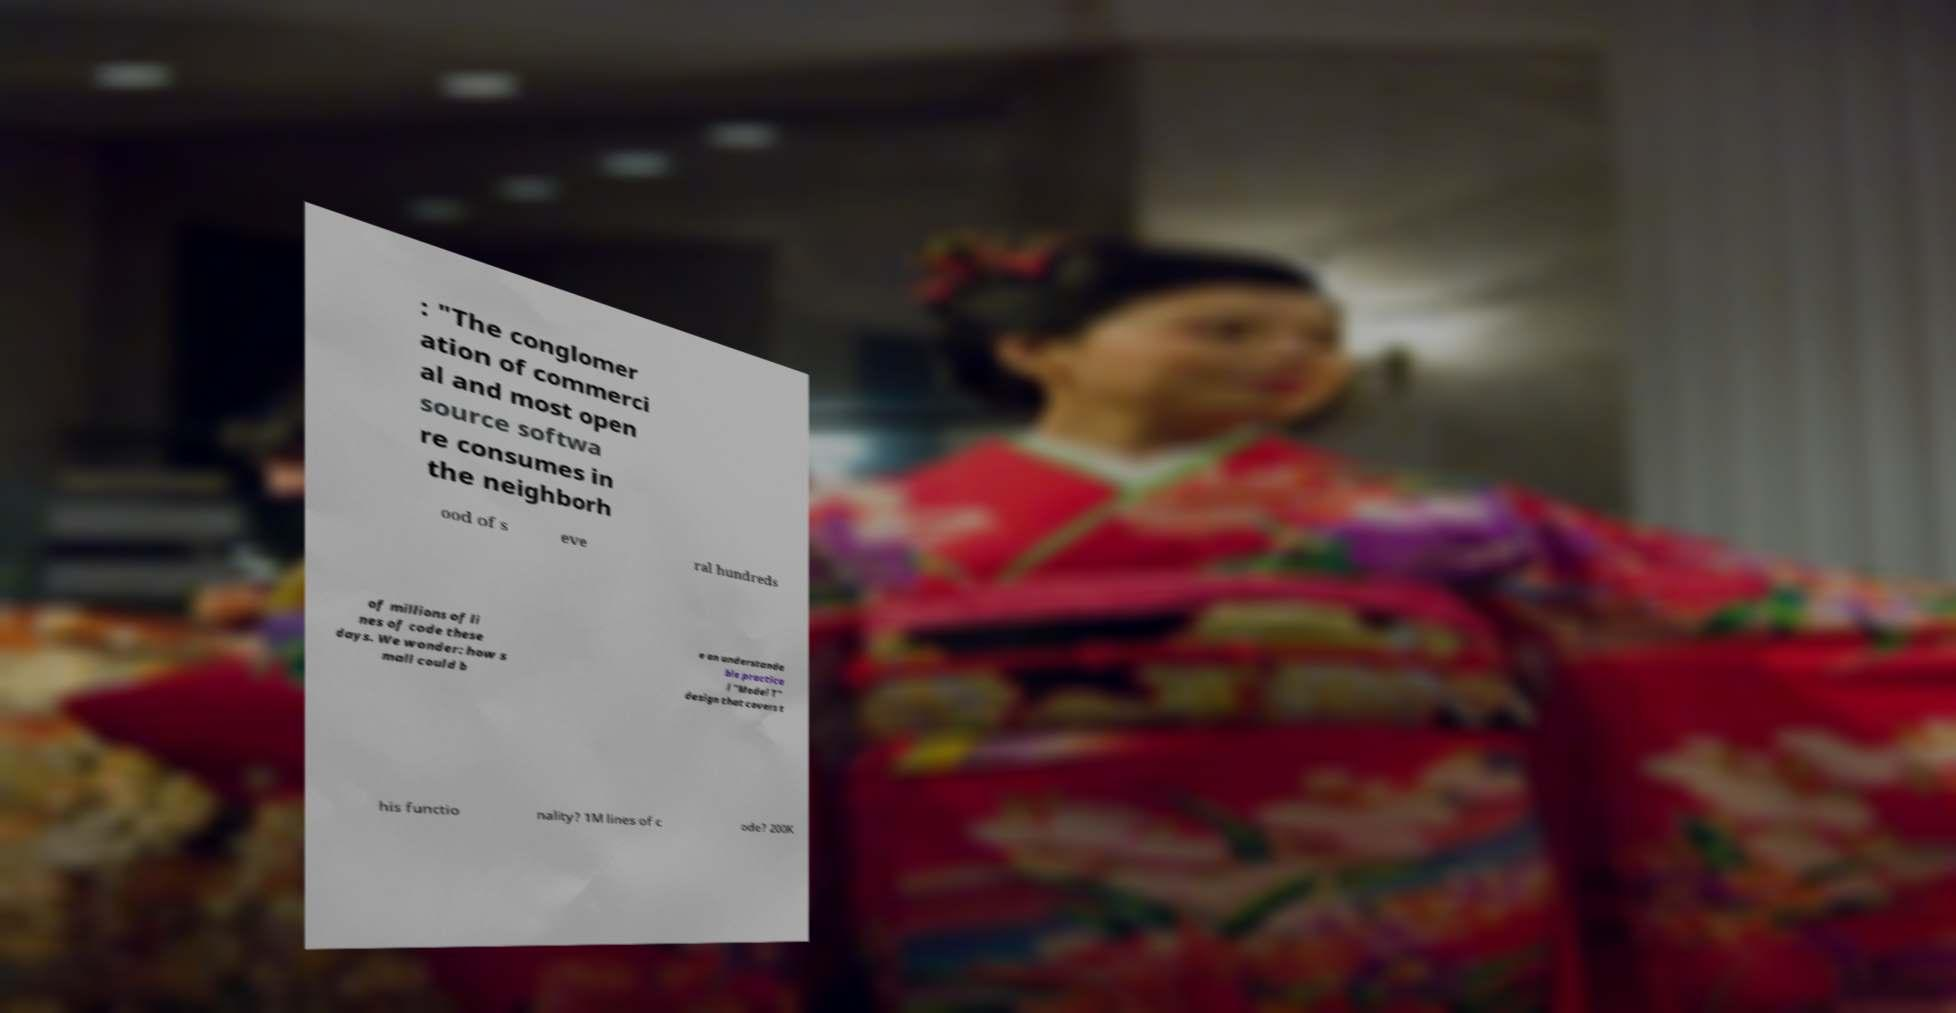Can you read and provide the text displayed in the image?This photo seems to have some interesting text. Can you extract and type it out for me? : "The conglomer ation of commerci al and most open source softwa re consumes in the neighborh ood of s eve ral hundreds of millions of li nes of code these days. We wonder: how s mall could b e an understanda ble practica l "Model T" design that covers t his functio nality? 1M lines of c ode? 200K 